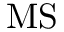<formula> <loc_0><loc_0><loc_500><loc_500>M S</formula> 